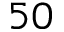<formula> <loc_0><loc_0><loc_500><loc_500>5 0</formula> 